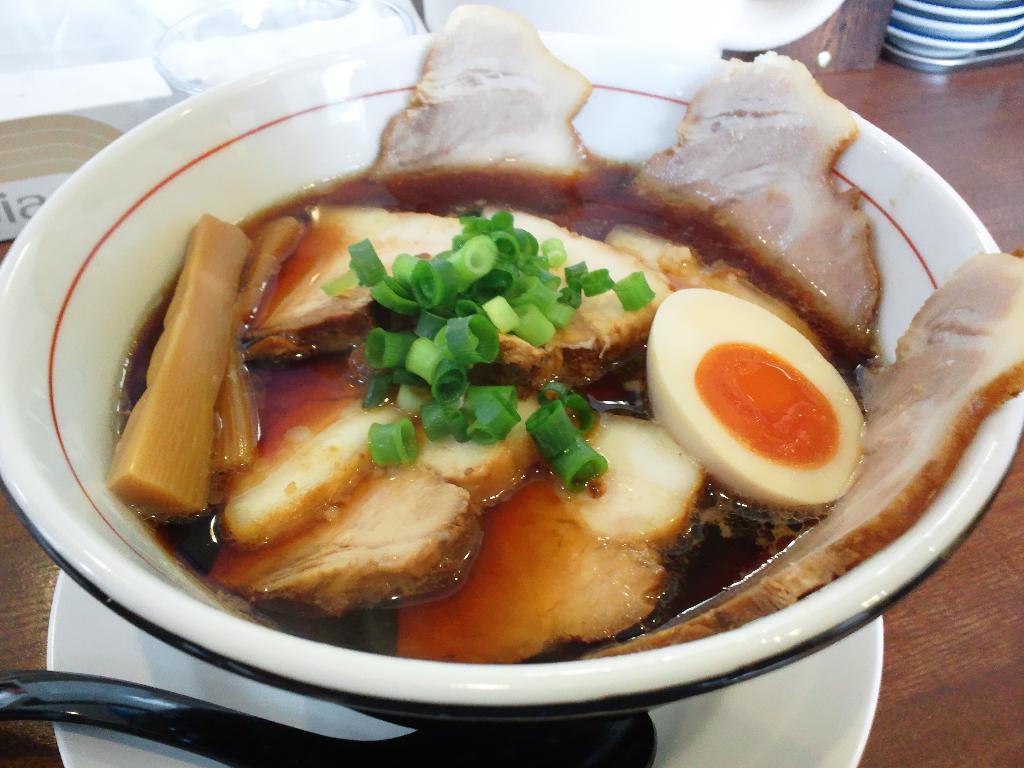Can you describe this image briefly? In this image I can see the bowl with food. The bowl is in white and red color. The food is colorful. To the side I can see the spoon on the white plate. These are on the brown color surface. 